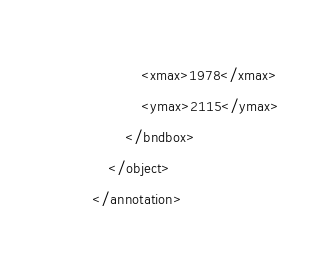Convert code to text. <code><loc_0><loc_0><loc_500><loc_500><_XML_>			<xmax>1978</xmax>
			<ymax>2115</ymax>
		</bndbox>
	</object>
</annotation>
</code> 